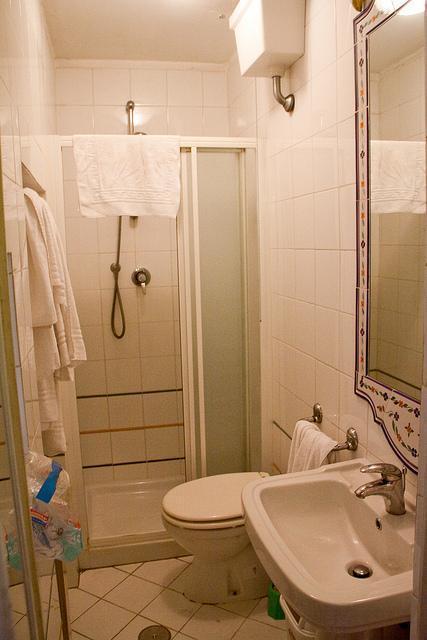How many towels are there?
Give a very brief answer. 3. 